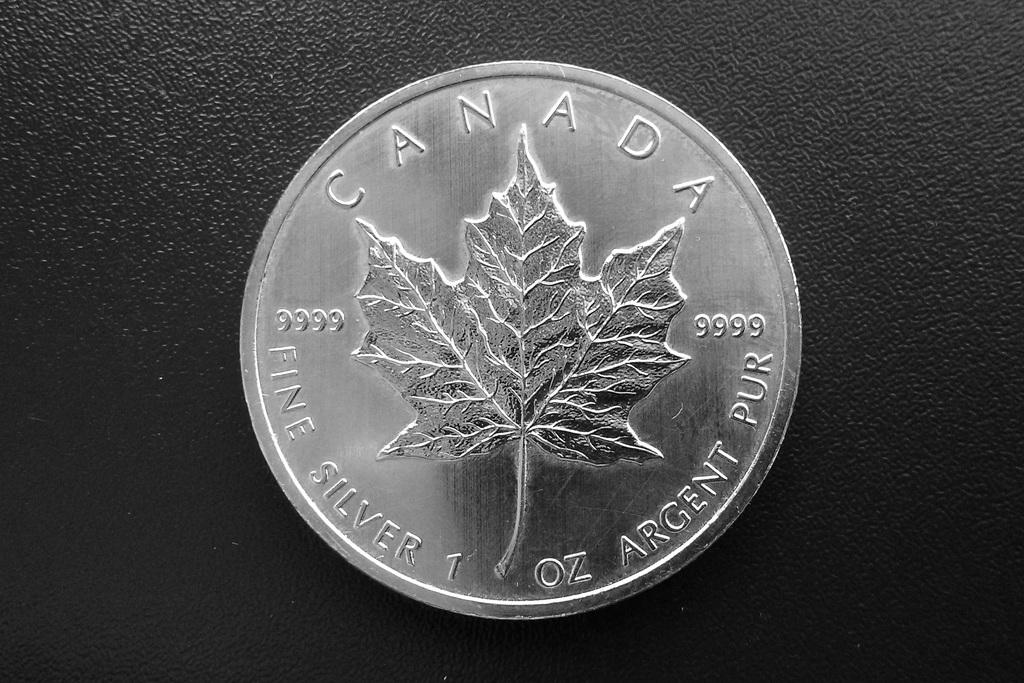<image>
Summarize the visual content of the image. A canadian coin sitting on a black background. 